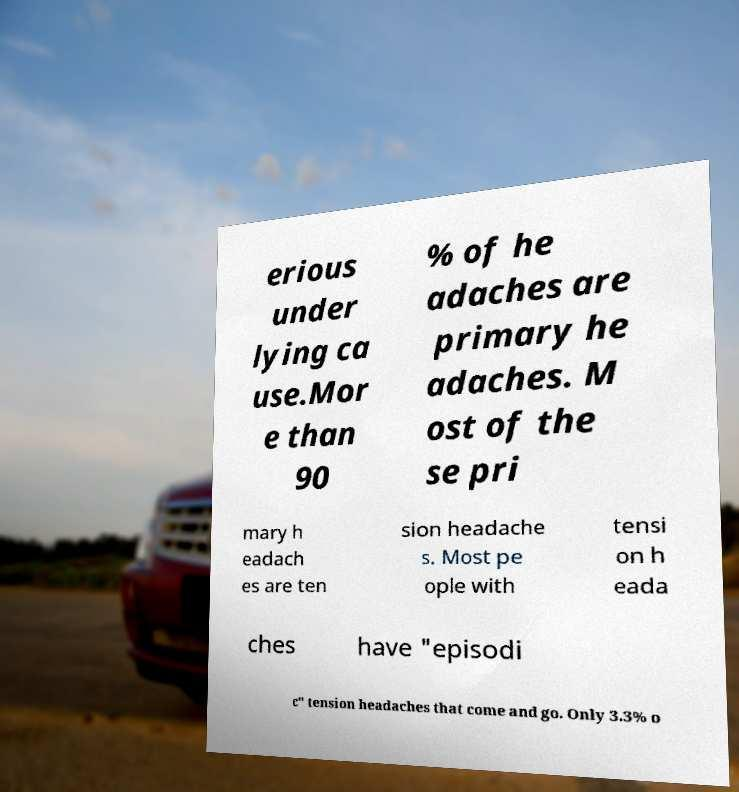Please identify and transcribe the text found in this image. erious under lying ca use.Mor e than 90 % of he adaches are primary he adaches. M ost of the se pri mary h eadach es are ten sion headache s. Most pe ople with tensi on h eada ches have "episodi c" tension headaches that come and go. Only 3.3% o 